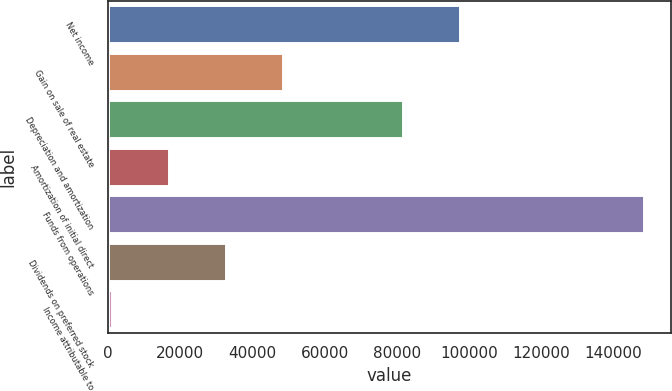Convert chart to OTSL. <chart><loc_0><loc_0><loc_500><loc_500><bar_chart><fcel>Net income<fcel>Gain on sale of real estate<fcel>Depreciation and amortization<fcel>Amortization of initial direct<fcel>Funds from operations<fcel>Dividends on preferred stock<fcel>Income attributable to<nl><fcel>97452.6<fcel>48465.8<fcel>81649<fcel>16858.6<fcel>148671<fcel>32662.2<fcel>1055<nl></chart> 